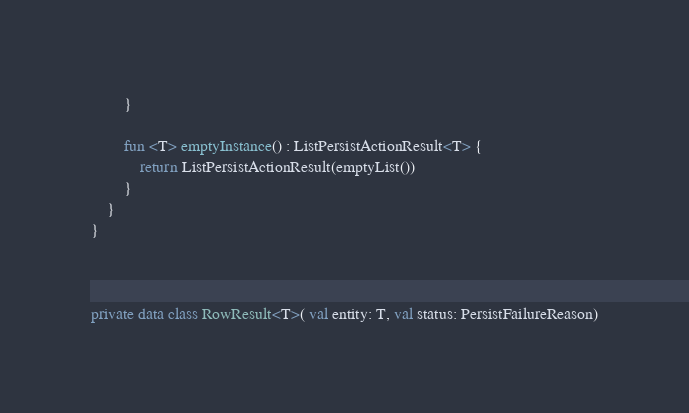Convert code to text. <code><loc_0><loc_0><loc_500><loc_500><_Kotlin_>        }

        fun <T> emptyInstance() : ListPersistActionResult<T> {
            return ListPersistActionResult(emptyList())
        }
    }
}



private data class RowResult<T>( val entity: T, val status: PersistFailureReason)




</code> 